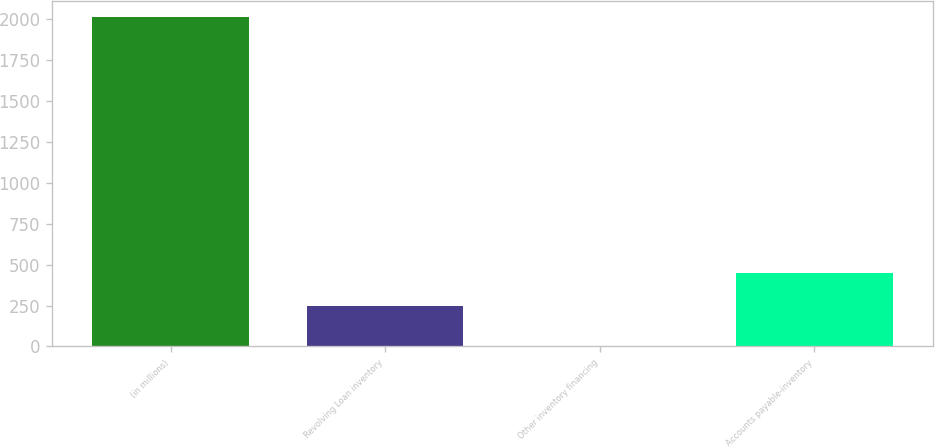<chart> <loc_0><loc_0><loc_500><loc_500><bar_chart><fcel>(in millions)<fcel>Revolving Loan inventory<fcel>Other inventory financing<fcel>Accounts payable-inventory<nl><fcel>2012<fcel>248.3<fcel>0.9<fcel>449.41<nl></chart> 